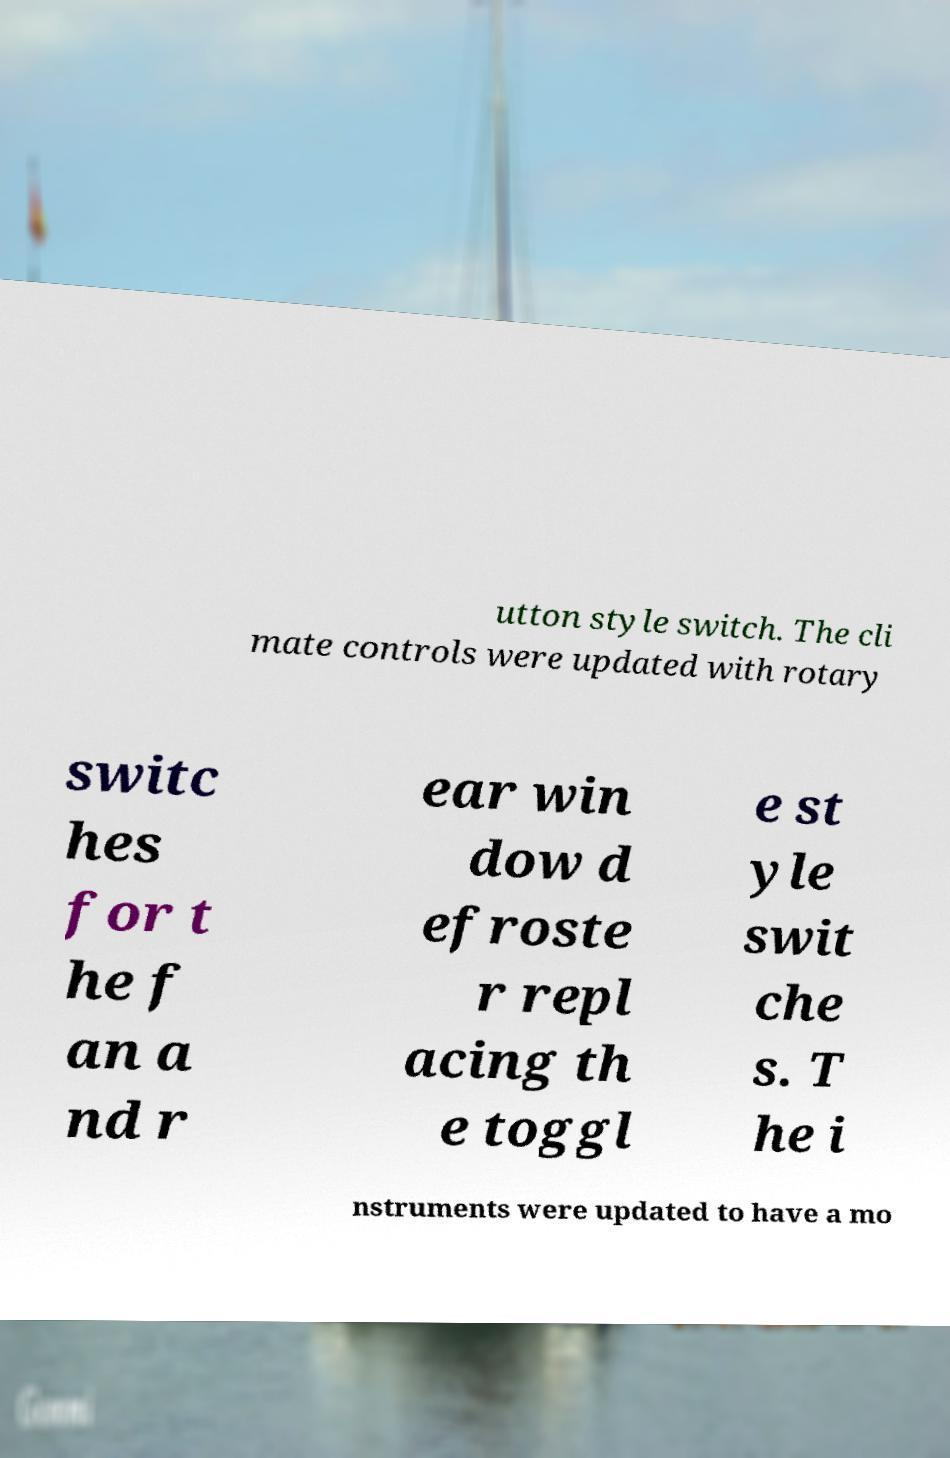Please read and relay the text visible in this image. What does it say? utton style switch. The cli mate controls were updated with rotary switc hes for t he f an a nd r ear win dow d efroste r repl acing th e toggl e st yle swit che s. T he i nstruments were updated to have a mo 